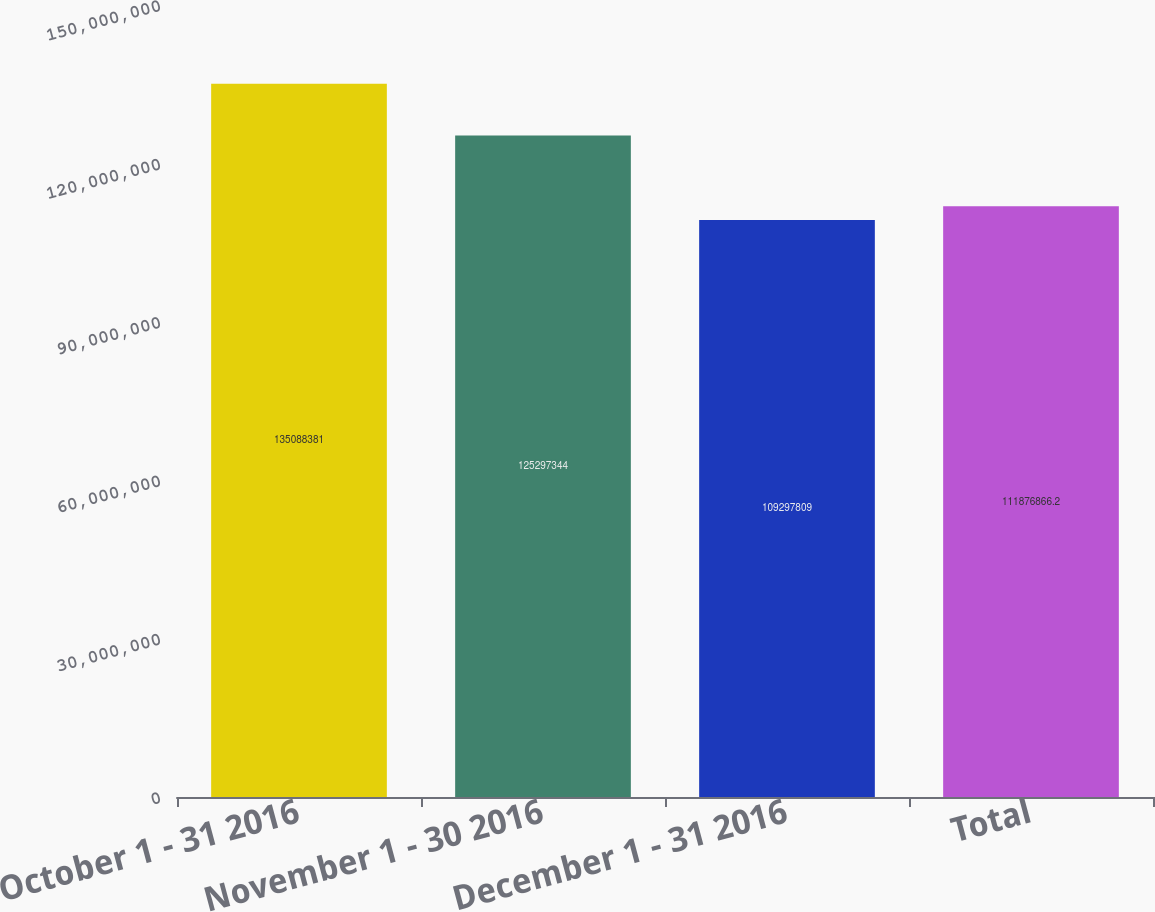Convert chart to OTSL. <chart><loc_0><loc_0><loc_500><loc_500><bar_chart><fcel>October 1 - 31 2016<fcel>November 1 - 30 2016<fcel>December 1 - 31 2016<fcel>Total<nl><fcel>1.35088e+08<fcel>1.25297e+08<fcel>1.09298e+08<fcel>1.11877e+08<nl></chart> 